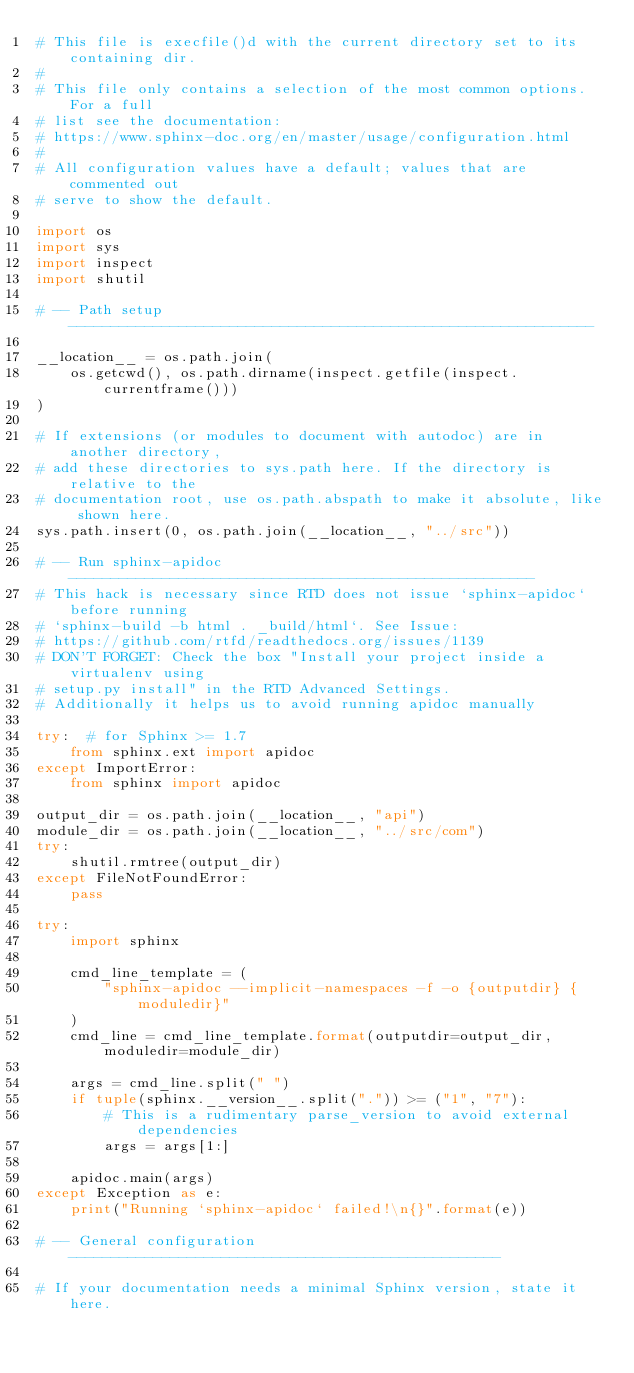<code> <loc_0><loc_0><loc_500><loc_500><_Python_># This file is execfile()d with the current directory set to its containing dir.
#
# This file only contains a selection of the most common options. For a full
# list see the documentation:
# https://www.sphinx-doc.org/en/master/usage/configuration.html
#
# All configuration values have a default; values that are commented out
# serve to show the default.

import os
import sys
import inspect
import shutil

# -- Path setup --------------------------------------------------------------

__location__ = os.path.join(
    os.getcwd(), os.path.dirname(inspect.getfile(inspect.currentframe()))
)

# If extensions (or modules to document with autodoc) are in another directory,
# add these directories to sys.path here. If the directory is relative to the
# documentation root, use os.path.abspath to make it absolute, like shown here.
sys.path.insert(0, os.path.join(__location__, "../src"))

# -- Run sphinx-apidoc -------------------------------------------------------
# This hack is necessary since RTD does not issue `sphinx-apidoc` before running
# `sphinx-build -b html . _build/html`. See Issue:
# https://github.com/rtfd/readthedocs.org/issues/1139
# DON'T FORGET: Check the box "Install your project inside a virtualenv using
# setup.py install" in the RTD Advanced Settings.
# Additionally it helps us to avoid running apidoc manually

try:  # for Sphinx >= 1.7
    from sphinx.ext import apidoc
except ImportError:
    from sphinx import apidoc

output_dir = os.path.join(__location__, "api")
module_dir = os.path.join(__location__, "../src/com")
try:
    shutil.rmtree(output_dir)
except FileNotFoundError:
    pass

try:
    import sphinx

    cmd_line_template = (
        "sphinx-apidoc --implicit-namespaces -f -o {outputdir} {moduledir}"
    )
    cmd_line = cmd_line_template.format(outputdir=output_dir, moduledir=module_dir)

    args = cmd_line.split(" ")
    if tuple(sphinx.__version__.split(".")) >= ("1", "7"):
        # This is a rudimentary parse_version to avoid external dependencies
        args = args[1:]

    apidoc.main(args)
except Exception as e:
    print("Running `sphinx-apidoc` failed!\n{}".format(e))

# -- General configuration ---------------------------------------------------

# If your documentation needs a minimal Sphinx version, state it here.</code> 